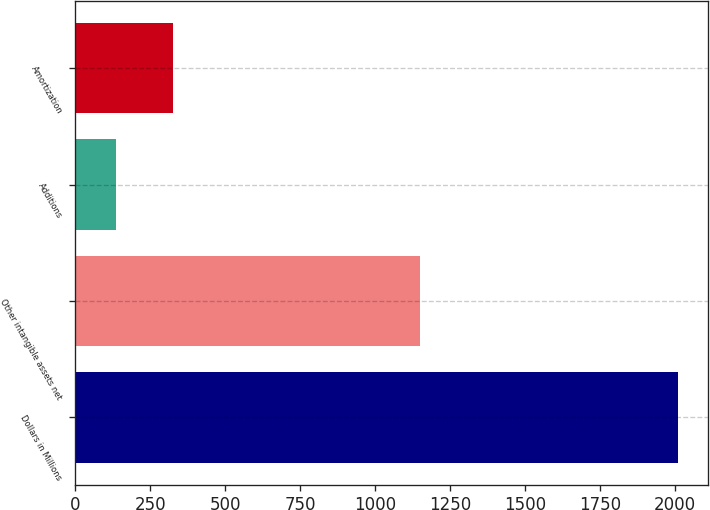Convert chart. <chart><loc_0><loc_0><loc_500><loc_500><bar_chart><fcel>Dollars in Millions<fcel>Other intangible assets net<fcel>Additions<fcel>Amortization<nl><fcel>2008<fcel>1151<fcel>138<fcel>325<nl></chart> 